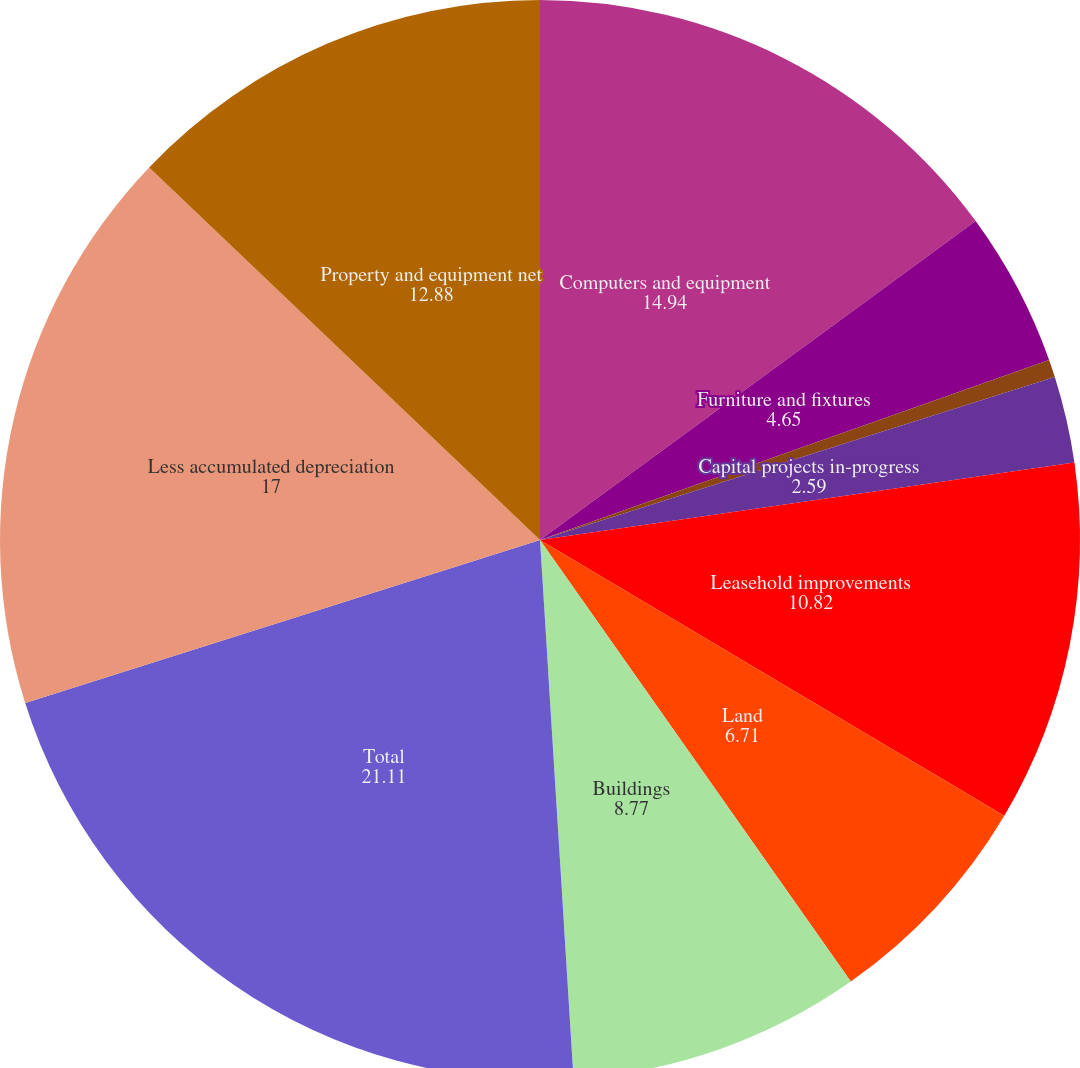<chart> <loc_0><loc_0><loc_500><loc_500><pie_chart><fcel>Computers and equipment<fcel>Furniture and fixtures<fcel>Server hardware under capital<fcel>Capital projects in-progress<fcel>Leasehold improvements<fcel>Land<fcel>Buildings<fcel>Total<fcel>Less accumulated depreciation<fcel>Property and equipment net<nl><fcel>14.94%<fcel>4.65%<fcel>0.53%<fcel>2.59%<fcel>10.82%<fcel>6.71%<fcel>8.77%<fcel>21.11%<fcel>17.0%<fcel>12.88%<nl></chart> 